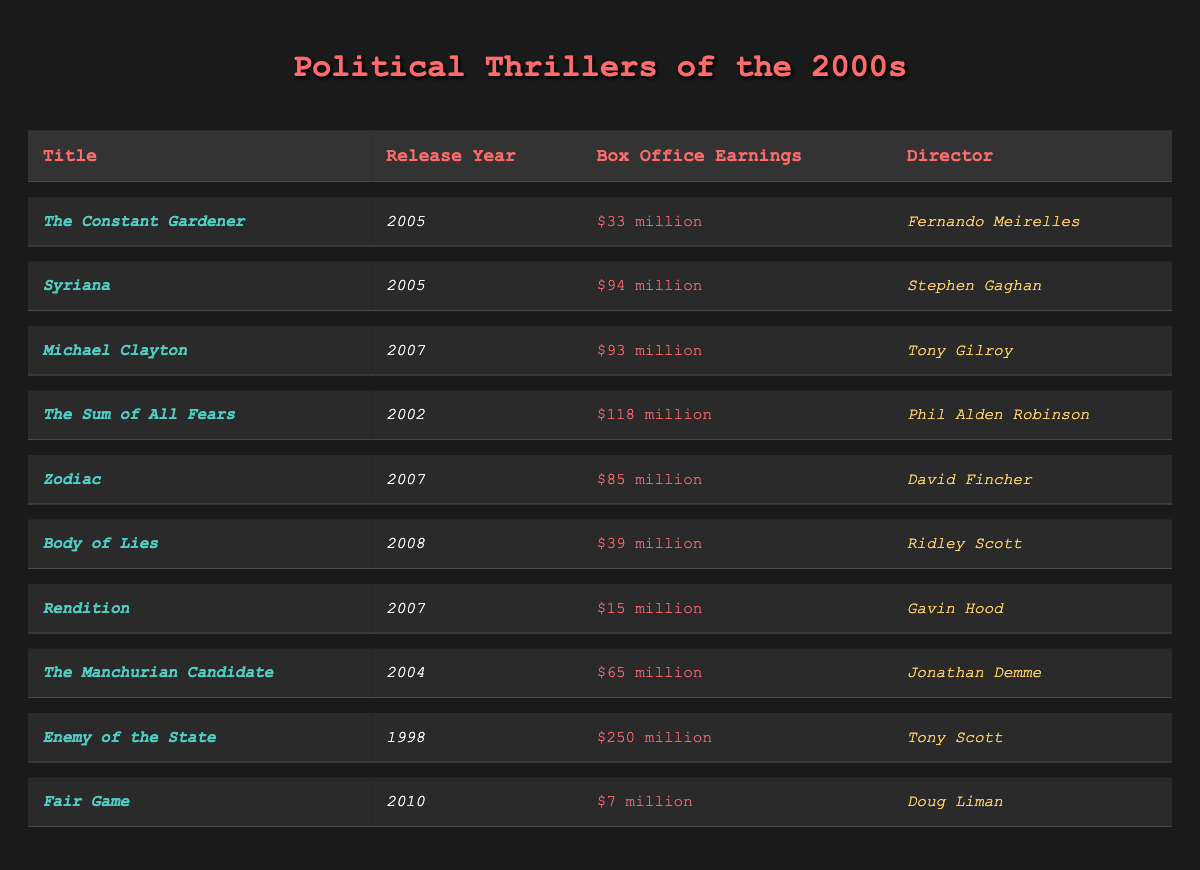What is the highest box office earning among the political thrillers listed? The entries in the box office earnings column show "The Sum of All Fears" with $118 million as the highest amount listed.
Answer: $118 million How many films listed were released in 2005? There are two films from 2005: *The Constant Gardener* and *Syriana*.
Answer: 2 Which director was responsible for the film with the lowest box office earning? The film with the lowest box office earning is *Rendition* at $15 million, and it was directed by *Gavin Hood*.
Answer: *Gavin Hood* What is the difference in box office earnings between the highest and lowest film released in 2007? The highest earning film from 2007 is *Michael Clayton* with $93 million and the lowest is *Rendition* with $15 million. The difference is $93 million - $15 million = $78 million.
Answer: $78 million Did *Enemy of the State* release in the 2000s? No, *Enemy of the State* was released in 1998, so it is not part of the 2000s list.
Answer: No What is the average box office earning for films directed by *Ridley Scott*? The only film from the list directed by *Ridley Scott* is *Body of Lies*, with earnings of $39 million. The average for one film is $39 million itself.
Answer: $39 million Which film had the highest earnings released in 2004 and what were those earnings? The film that was released in 2004 is *The Manchurian Candidate*, which had earnings of $65 million, making it the highest for that year.
Answer: $65 million How many films in this list have earnings greater than $90 million? Two films have earnings greater than $90 million: *Syriana* with $94 million and *Michael Clayton* with $93 million.
Answer: 2 What is the total box office earnings of all films released in 2005? The box office earnings for the films released in 2005 are *The Constant Gardener* ($33 million) and *Syriana* ($94 million). The total is $33 million + $94 million = $127 million.
Answer: $127 million Which film has the same release year as *Zodiac*, and what is its box office earning? *Zodiac* was released in 2007, and another film released in the same year is *Michael Clayton* with earnings of $93 million.
Answer: *Michael Clayton*, $93 million 